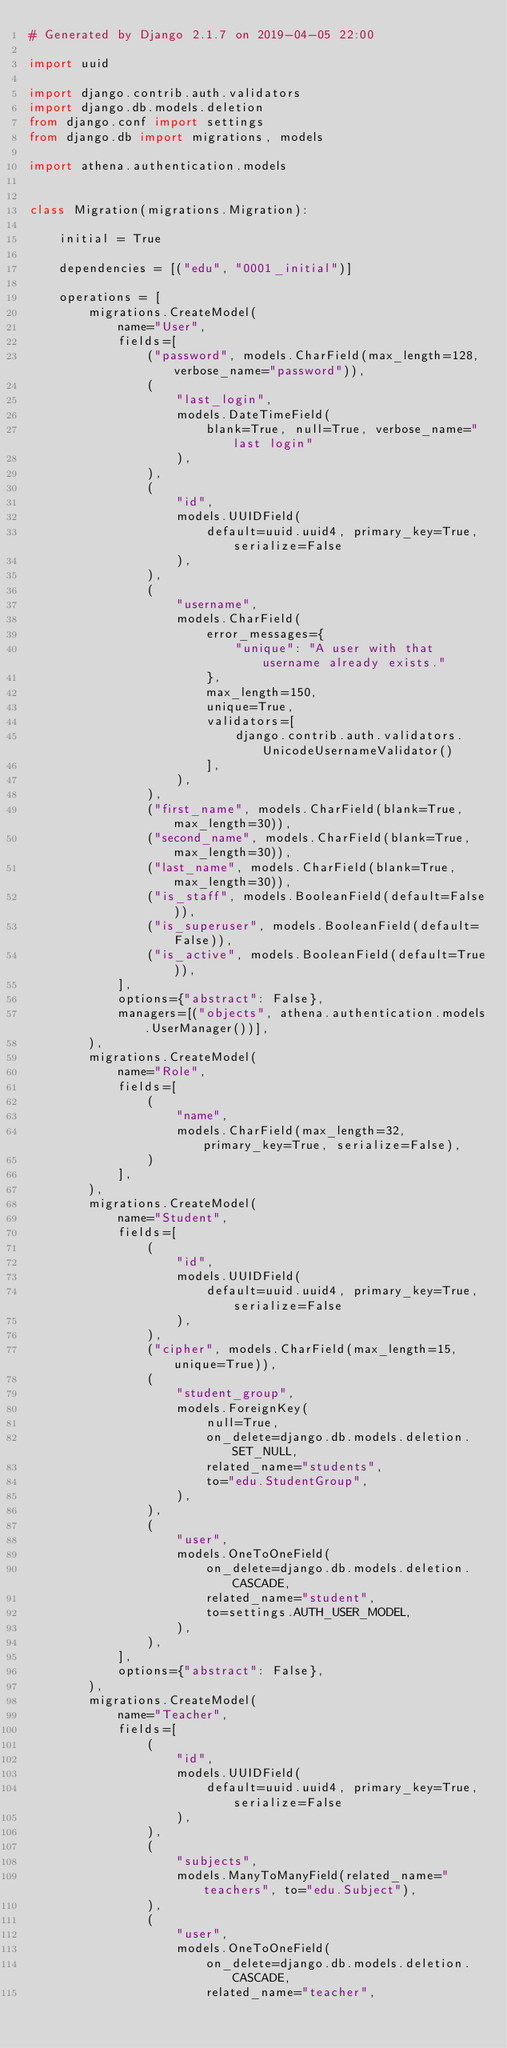<code> <loc_0><loc_0><loc_500><loc_500><_Python_># Generated by Django 2.1.7 on 2019-04-05 22:00

import uuid

import django.contrib.auth.validators
import django.db.models.deletion
from django.conf import settings
from django.db import migrations, models

import athena.authentication.models


class Migration(migrations.Migration):

    initial = True

    dependencies = [("edu", "0001_initial")]

    operations = [
        migrations.CreateModel(
            name="User",
            fields=[
                ("password", models.CharField(max_length=128, verbose_name="password")),
                (
                    "last_login",
                    models.DateTimeField(
                        blank=True, null=True, verbose_name="last login"
                    ),
                ),
                (
                    "id",
                    models.UUIDField(
                        default=uuid.uuid4, primary_key=True, serialize=False
                    ),
                ),
                (
                    "username",
                    models.CharField(
                        error_messages={
                            "unique": "A user with that username already exists."
                        },
                        max_length=150,
                        unique=True,
                        validators=[
                            django.contrib.auth.validators.UnicodeUsernameValidator()
                        ],
                    ),
                ),
                ("first_name", models.CharField(blank=True, max_length=30)),
                ("second_name", models.CharField(blank=True, max_length=30)),
                ("last_name", models.CharField(blank=True, max_length=30)),
                ("is_staff", models.BooleanField(default=False)),
                ("is_superuser", models.BooleanField(default=False)),
                ("is_active", models.BooleanField(default=True)),
            ],
            options={"abstract": False},
            managers=[("objects", athena.authentication.models.UserManager())],
        ),
        migrations.CreateModel(
            name="Role",
            fields=[
                (
                    "name",
                    models.CharField(max_length=32, primary_key=True, serialize=False),
                )
            ],
        ),
        migrations.CreateModel(
            name="Student",
            fields=[
                (
                    "id",
                    models.UUIDField(
                        default=uuid.uuid4, primary_key=True, serialize=False
                    ),
                ),
                ("cipher", models.CharField(max_length=15, unique=True)),
                (
                    "student_group",
                    models.ForeignKey(
                        null=True,
                        on_delete=django.db.models.deletion.SET_NULL,
                        related_name="students",
                        to="edu.StudentGroup",
                    ),
                ),
                (
                    "user",
                    models.OneToOneField(
                        on_delete=django.db.models.deletion.CASCADE,
                        related_name="student",
                        to=settings.AUTH_USER_MODEL,
                    ),
                ),
            ],
            options={"abstract": False},
        ),
        migrations.CreateModel(
            name="Teacher",
            fields=[
                (
                    "id",
                    models.UUIDField(
                        default=uuid.uuid4, primary_key=True, serialize=False
                    ),
                ),
                (
                    "subjects",
                    models.ManyToManyField(related_name="teachers", to="edu.Subject"),
                ),
                (
                    "user",
                    models.OneToOneField(
                        on_delete=django.db.models.deletion.CASCADE,
                        related_name="teacher",</code> 